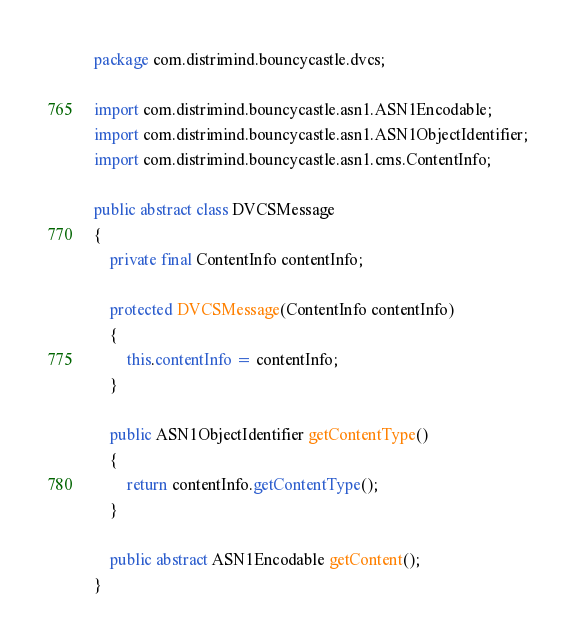Convert code to text. <code><loc_0><loc_0><loc_500><loc_500><_Java_>package com.distrimind.bouncycastle.dvcs;

import com.distrimind.bouncycastle.asn1.ASN1Encodable;
import com.distrimind.bouncycastle.asn1.ASN1ObjectIdentifier;
import com.distrimind.bouncycastle.asn1.cms.ContentInfo;

public abstract class DVCSMessage
{
    private final ContentInfo contentInfo;

    protected DVCSMessage(ContentInfo contentInfo)
    {
        this.contentInfo = contentInfo;
    }

    public ASN1ObjectIdentifier getContentType()
    {
        return contentInfo.getContentType();
    }

    public abstract ASN1Encodable getContent();
}
</code> 